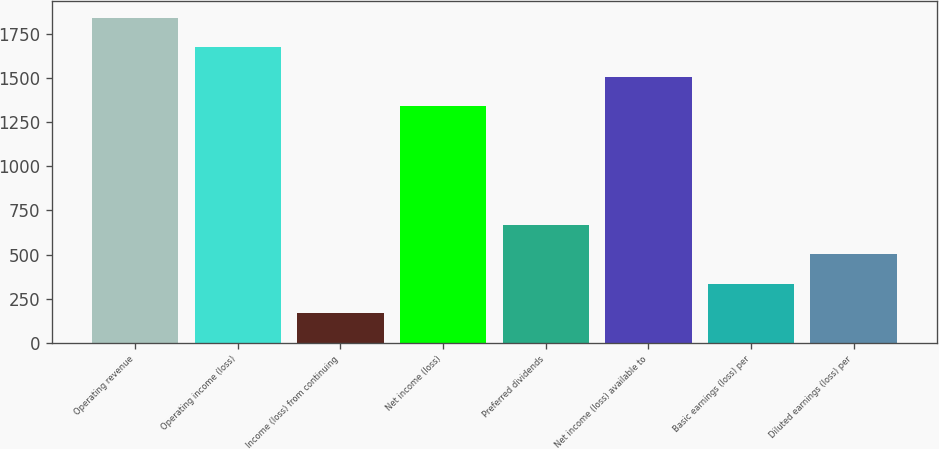Convert chart. <chart><loc_0><loc_0><loc_500><loc_500><bar_chart><fcel>Operating revenue<fcel>Operating income (loss)<fcel>Income (loss) from continuing<fcel>Net income (loss)<fcel>Preferred dividends<fcel>Net income (loss) available to<fcel>Basic earnings (loss) per<fcel>Diluted earnings (loss) per<nl><fcel>1841.3<fcel>1673.96<fcel>167.9<fcel>1339.28<fcel>669.92<fcel>1506.62<fcel>335.24<fcel>502.58<nl></chart> 